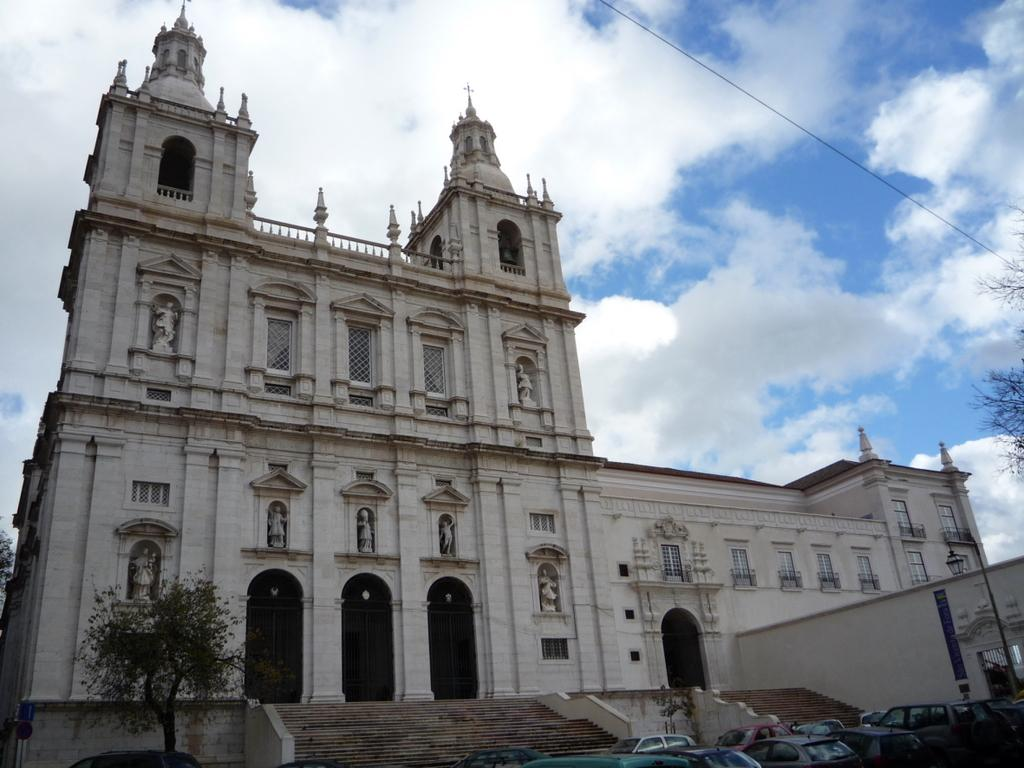What is located at the bottom of the image? There are vehicles, poles, trees, and steps at the bottom of the image. What can be seen in the background of the image? There is a building, windows, doors, and clouds in the sky in the background of the image. Can you tell me how many servants are visible in the image? There are no servants present in the image. Is there an airplane flying in the sky in the image? No, there is no airplane visible in the image. 